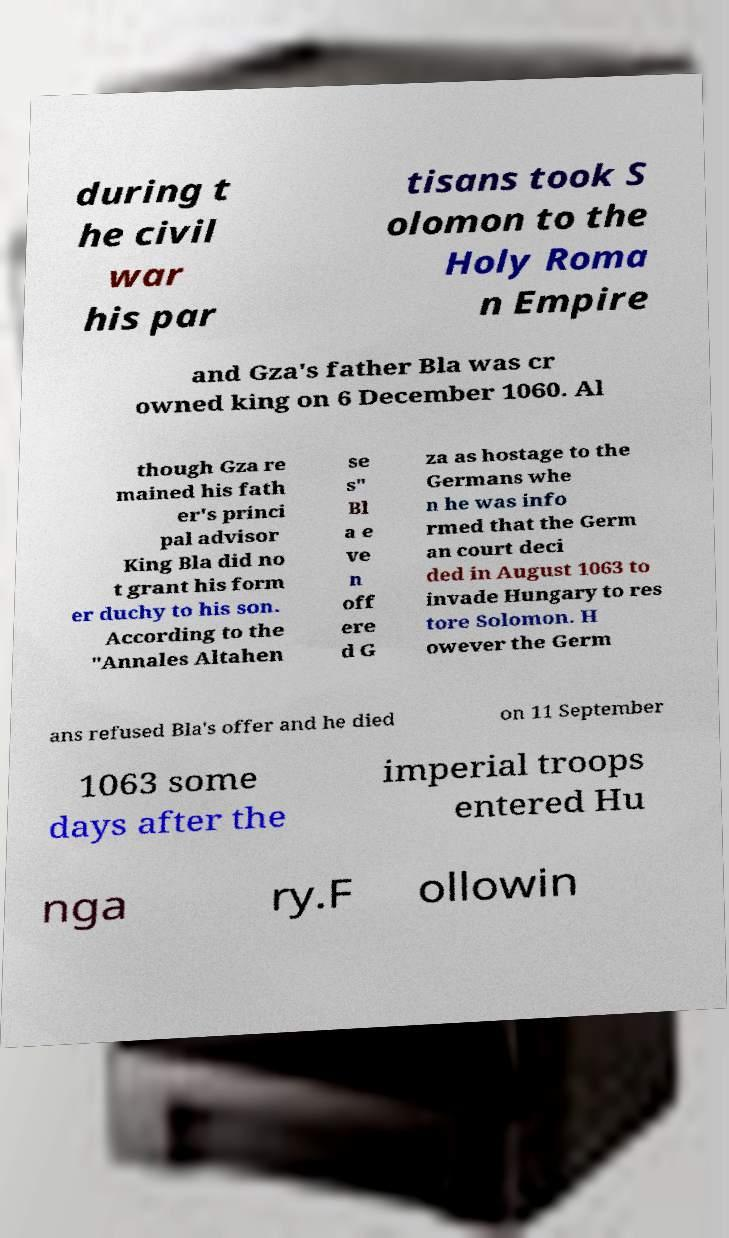Can you read and provide the text displayed in the image?This photo seems to have some interesting text. Can you extract and type it out for me? during t he civil war his par tisans took S olomon to the Holy Roma n Empire and Gza's father Bla was cr owned king on 6 December 1060. Al though Gza re mained his fath er's princi pal advisor King Bla did no t grant his form er duchy to his son. According to the "Annales Altahen se s" Bl a e ve n off ere d G za as hostage to the Germans whe n he was info rmed that the Germ an court deci ded in August 1063 to invade Hungary to res tore Solomon. H owever the Germ ans refused Bla's offer and he died on 11 September 1063 some days after the imperial troops entered Hu nga ry.F ollowin 